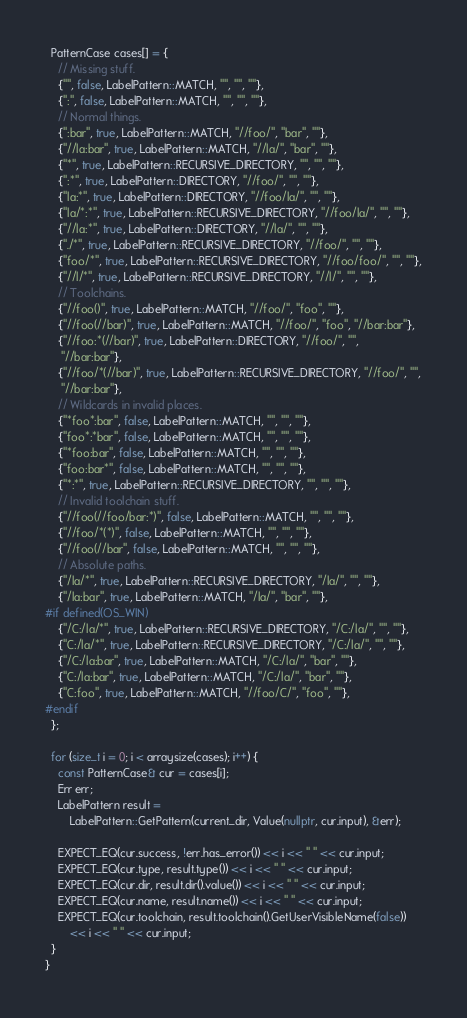Convert code to text. <code><loc_0><loc_0><loc_500><loc_500><_C++_>  PatternCase cases[] = {
    // Missing stuff.
    {"", false, LabelPattern::MATCH, "", "", ""},
    {":", false, LabelPattern::MATCH, "", "", ""},
    // Normal things.
    {":bar", true, LabelPattern::MATCH, "//foo/", "bar", ""},
    {"//la:bar", true, LabelPattern::MATCH, "//la/", "bar", ""},
    {"*", true, LabelPattern::RECURSIVE_DIRECTORY, "", "", ""},
    {":*", true, LabelPattern::DIRECTORY, "//foo/", "", ""},
    {"la:*", true, LabelPattern::DIRECTORY, "//foo/la/", "", ""},
    {"la/*:*", true, LabelPattern::RECURSIVE_DIRECTORY, "//foo/la/", "", ""},
    {"//la:*", true, LabelPattern::DIRECTORY, "//la/", "", ""},
    {"./*", true, LabelPattern::RECURSIVE_DIRECTORY, "//foo/", "", ""},
    {"foo/*", true, LabelPattern::RECURSIVE_DIRECTORY, "//foo/foo/", "", ""},
    {"//l/*", true, LabelPattern::RECURSIVE_DIRECTORY, "//l/", "", ""},
    // Toolchains.
    {"//foo()", true, LabelPattern::MATCH, "//foo/", "foo", ""},
    {"//foo(//bar)", true, LabelPattern::MATCH, "//foo/", "foo", "//bar:bar"},
    {"//foo:*(//bar)", true, LabelPattern::DIRECTORY, "//foo/", "",
     "//bar:bar"},
    {"//foo/*(//bar)", true, LabelPattern::RECURSIVE_DIRECTORY, "//foo/", "",
     "//bar:bar"},
    // Wildcards in invalid places.
    {"*foo*:bar", false, LabelPattern::MATCH, "", "", ""},
    {"foo*:*bar", false, LabelPattern::MATCH, "", "", ""},
    {"*foo:bar", false, LabelPattern::MATCH, "", "", ""},
    {"foo:bar*", false, LabelPattern::MATCH, "", "", ""},
    {"*:*", true, LabelPattern::RECURSIVE_DIRECTORY, "", "", ""},
    // Invalid toolchain stuff.
    {"//foo(//foo/bar:*)", false, LabelPattern::MATCH, "", "", ""},
    {"//foo/*(*)", false, LabelPattern::MATCH, "", "", ""},
    {"//foo(//bar", false, LabelPattern::MATCH, "", "", ""},
    // Absolute paths.
    {"/la/*", true, LabelPattern::RECURSIVE_DIRECTORY, "/la/", "", ""},
    {"/la:bar", true, LabelPattern::MATCH, "/la/", "bar", ""},
#if defined(OS_WIN)
    {"/C:/la/*", true, LabelPattern::RECURSIVE_DIRECTORY, "/C:/la/", "", ""},
    {"C:/la/*", true, LabelPattern::RECURSIVE_DIRECTORY, "/C:/la/", "", ""},
    {"/C:/la:bar", true, LabelPattern::MATCH, "/C:/la/", "bar", ""},
    {"C:/la:bar", true, LabelPattern::MATCH, "/C:/la/", "bar", ""},
    {"C:foo", true, LabelPattern::MATCH, "//foo/C/", "foo", ""},
#endif
  };

  for (size_t i = 0; i < arraysize(cases); i++) {
    const PatternCase& cur = cases[i];
    Err err;
    LabelPattern result =
        LabelPattern::GetPattern(current_dir, Value(nullptr, cur.input), &err);

    EXPECT_EQ(cur.success, !err.has_error()) << i << " " << cur.input;
    EXPECT_EQ(cur.type, result.type()) << i << " " << cur.input;
    EXPECT_EQ(cur.dir, result.dir().value()) << i << " " << cur.input;
    EXPECT_EQ(cur.name, result.name()) << i << " " << cur.input;
    EXPECT_EQ(cur.toolchain, result.toolchain().GetUserVisibleName(false))
        << i << " " << cur.input;
  }
}
</code> 